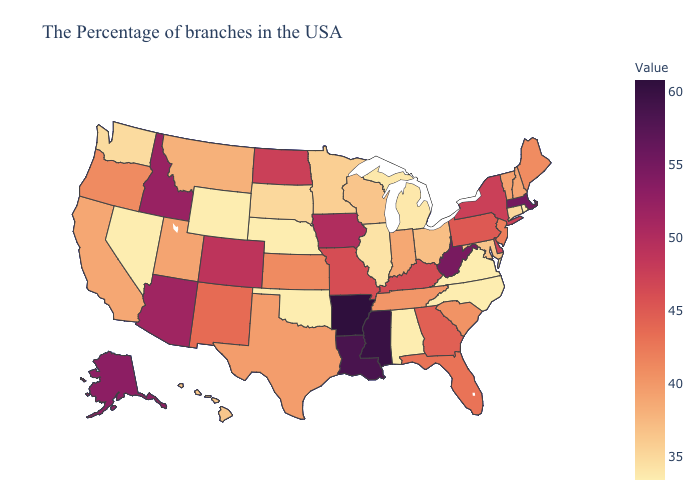Does the map have missing data?
Short answer required. No. Does Oklahoma have the lowest value in the South?
Short answer required. Yes. Which states have the lowest value in the West?
Short answer required. Wyoming, Nevada. Which states have the highest value in the USA?
Quick response, please. Arkansas. Among the states that border North Carolina , does South Carolina have the lowest value?
Be succinct. No. Does the map have missing data?
Write a very short answer. No. Does the map have missing data?
Answer briefly. No. Among the states that border Connecticut , does Rhode Island have the highest value?
Quick response, please. No. 